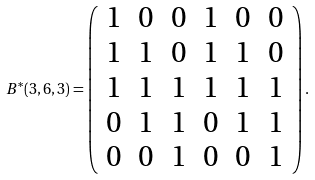<formula> <loc_0><loc_0><loc_500><loc_500>B ^ { * } ( 3 , 6 , 3 ) = \left ( \begin{array} { c c c c c c } 1 & 0 & 0 & 1 & 0 & 0 \\ 1 & 1 & 0 & 1 & 1 & 0 \\ 1 & 1 & 1 & 1 & 1 & 1 \\ 0 & 1 & 1 & 0 & 1 & 1 \\ 0 & 0 & 1 & 0 & 0 & 1 \end{array} \right ) .</formula> 